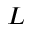<formula> <loc_0><loc_0><loc_500><loc_500>L</formula> 